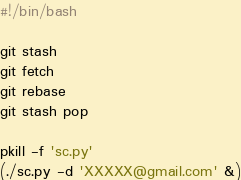Convert code to text. <code><loc_0><loc_0><loc_500><loc_500><_Bash_>#!/bin/bash

git stash
git fetch
git rebase
git stash pop

pkill -f 'sc.py'
(./sc.py -d 'XXXXX@gmail.com' &)
</code> 